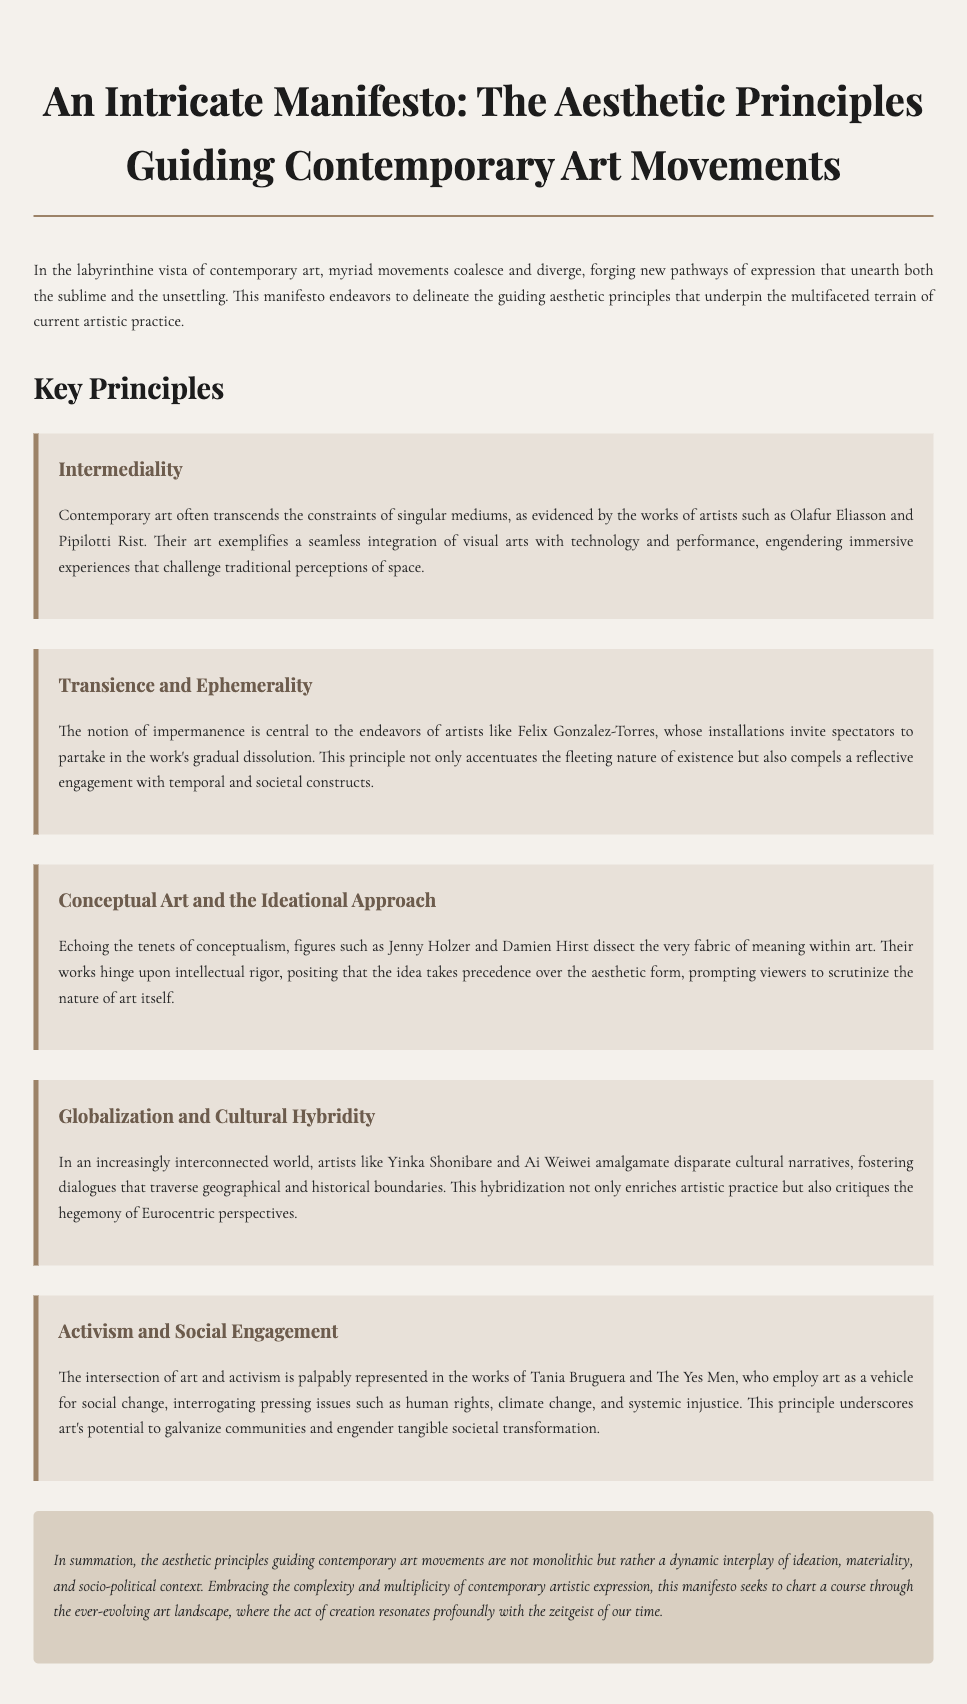what is the title of the document? The title is located at the top of the document and introduces the central theme.
Answer: An Intricate Manifesto: The Aesthetic Principles Guiding Contemporary Art Movements who are two artists mentioned in the principle of Intermediality? The principle of Intermediality cites specific artists as examples of its application within contemporary art.
Answer: Olafur Eliasson and Pipilotti Rist what aesthetic principle is associated with Felix Gonzalez-Torres? This principle emphasizes a specific concept central to Gonzales-Torres's installations which reflects a broader notion in contemporary art.
Answer: Transience and Ephemerality which artist is known for conceptual art according to the document? The document specifies artists who are representative of the ideational approach in contemporary art.
Answer: Jenny Holzer what principle critiques Eurocentric perspectives? This principle is described in relation to the increasing global interconnections and cultural dialogues formed through art.
Answer: Globalization and Cultural Hybridity how many principles are outlined in the document? The document explicitly lists aesthetic principles which are numbered to clarify its structure.
Answer: Five what key aspect does the principle of Activism and Social Engagement highlight? This principle emphasizes a specific function of art in relation to societal issues, as detailed in the artists' works discussed.
Answer: Social change what is the concluding sentiment expressed in the document? The conclusion summarizes the overarching themes regarding the nature of contemporary art as articulated in the text.
Answer: A dynamic interplay of ideation, materiality, and socio-political context 